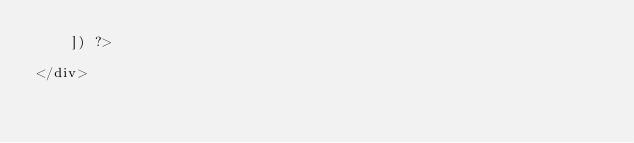<code> <loc_0><loc_0><loc_500><loc_500><_PHP_>    ]) ?>

</div>
</code> 